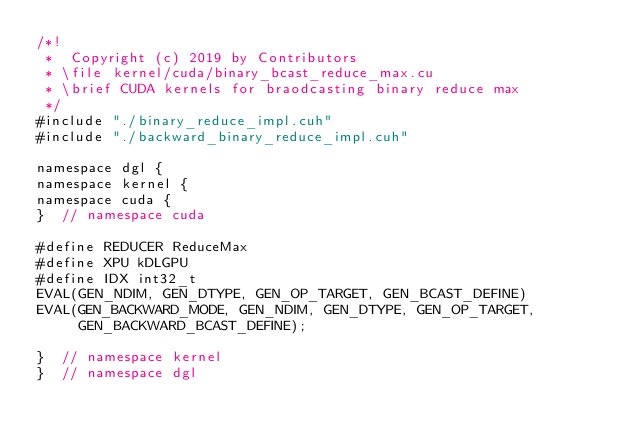Convert code to text. <code><loc_0><loc_0><loc_500><loc_500><_Cuda_>/*!
 *  Copyright (c) 2019 by Contributors
 * \file kernel/cuda/binary_bcast_reduce_max.cu
 * \brief CUDA kernels for braodcasting binary reduce max
 */
#include "./binary_reduce_impl.cuh"
#include "./backward_binary_reduce_impl.cuh"

namespace dgl {
namespace kernel {
namespace cuda {
}  // namespace cuda

#define REDUCER ReduceMax
#define XPU kDLGPU
#define IDX int32_t
EVAL(GEN_NDIM, GEN_DTYPE, GEN_OP_TARGET, GEN_BCAST_DEFINE)
EVAL(GEN_BACKWARD_MODE, GEN_NDIM, GEN_DTYPE, GEN_OP_TARGET,
     GEN_BACKWARD_BCAST_DEFINE);

}  // namespace kernel
}  // namespace dgl
</code> 